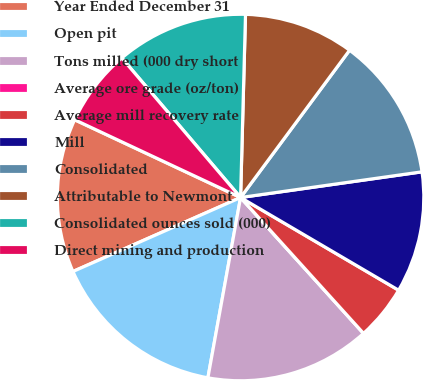Convert chart. <chart><loc_0><loc_0><loc_500><loc_500><pie_chart><fcel>Year Ended December 31<fcel>Open pit<fcel>Tons milled (000 dry short<fcel>Average ore grade (oz/ton)<fcel>Average mill recovery rate<fcel>Mill<fcel>Consolidated<fcel>Attributable to Newmont<fcel>Consolidated ounces sold (000)<fcel>Direct mining and production<nl><fcel>13.59%<fcel>15.53%<fcel>14.56%<fcel>0.0%<fcel>4.85%<fcel>10.68%<fcel>12.62%<fcel>9.71%<fcel>11.65%<fcel>6.8%<nl></chart> 